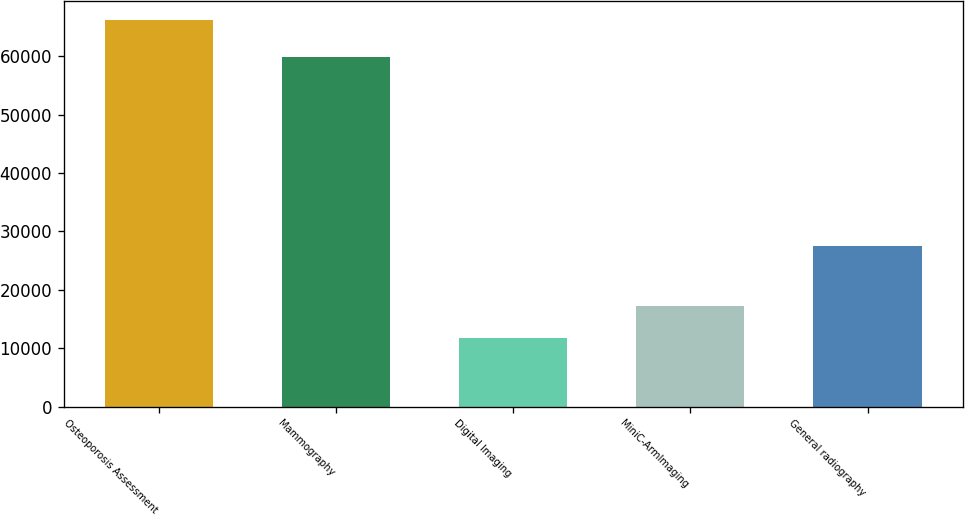Convert chart to OTSL. <chart><loc_0><loc_0><loc_500><loc_500><bar_chart><fcel>Osteoporosis Assessment<fcel>Mammography<fcel>Digital Imaging<fcel>MiniC-ArmImaging<fcel>General radiography<nl><fcel>66155<fcel>59943<fcel>11780<fcel>17217.5<fcel>27590<nl></chart> 